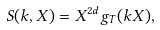Convert formula to latex. <formula><loc_0><loc_0><loc_500><loc_500>S ( { k } , X ) = X ^ { 2 d } g _ { T } ( k X ) ,</formula> 